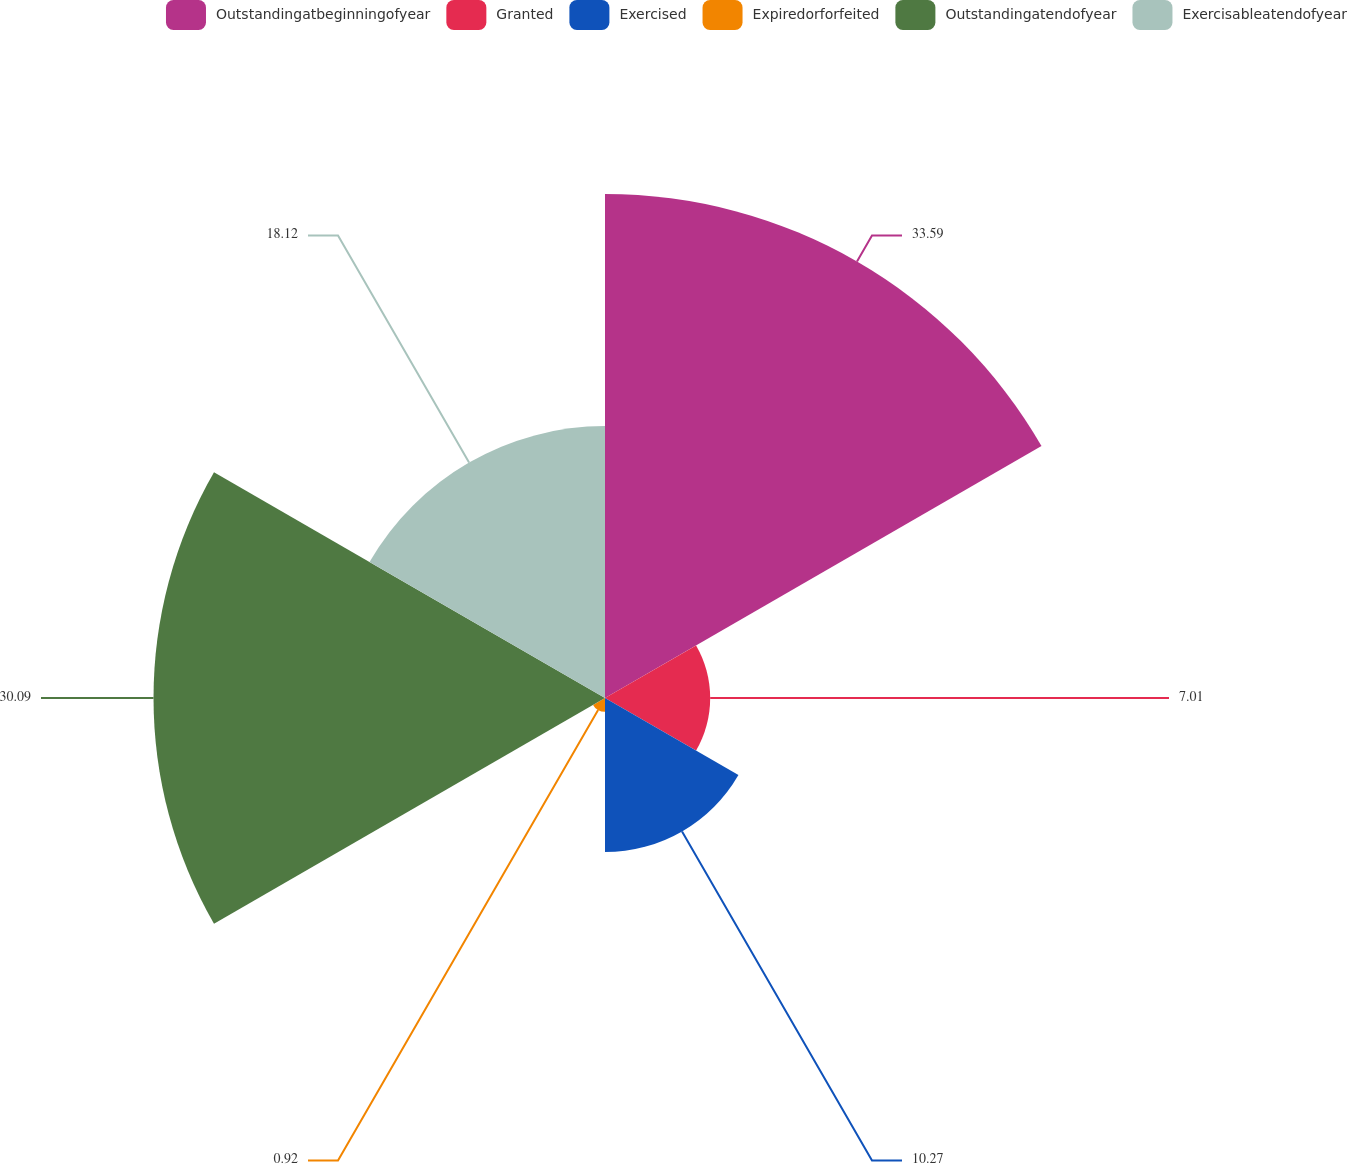<chart> <loc_0><loc_0><loc_500><loc_500><pie_chart><fcel>Outstandingatbeginningofyear<fcel>Granted<fcel>Exercised<fcel>Expiredorforfeited<fcel>Outstandingatendofyear<fcel>Exercisableatendofyear<nl><fcel>33.59%<fcel>7.01%<fcel>10.27%<fcel>0.92%<fcel>30.09%<fcel>18.12%<nl></chart> 